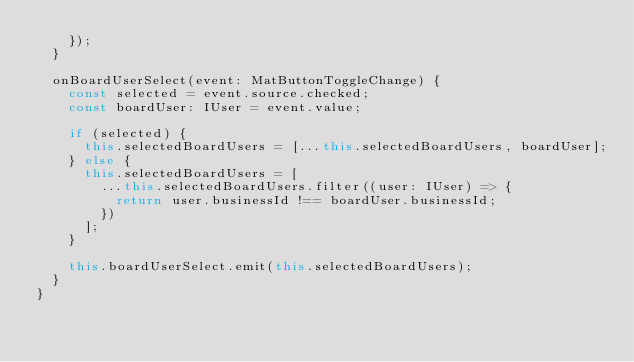Convert code to text. <code><loc_0><loc_0><loc_500><loc_500><_TypeScript_>    });
  }

  onBoardUserSelect(event: MatButtonToggleChange) {
    const selected = event.source.checked;
    const boardUser: IUser = event.value;

    if (selected) {
      this.selectedBoardUsers = [...this.selectedBoardUsers, boardUser];
    } else {
      this.selectedBoardUsers = [
        ...this.selectedBoardUsers.filter((user: IUser) => {
          return user.businessId !== boardUser.businessId;
        })
      ];
    }

    this.boardUserSelect.emit(this.selectedBoardUsers);
  }
}
</code> 